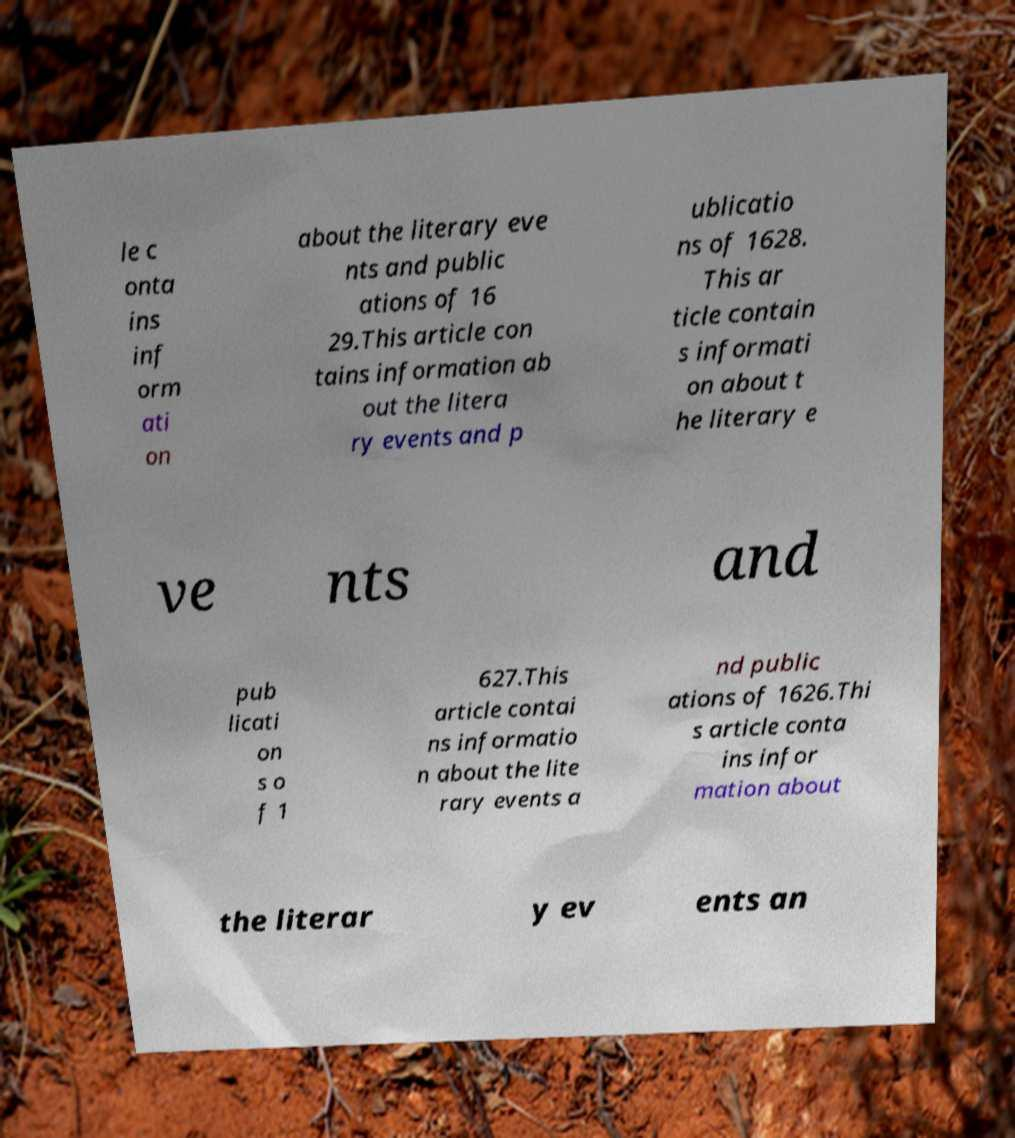Could you assist in decoding the text presented in this image and type it out clearly? le c onta ins inf orm ati on about the literary eve nts and public ations of 16 29.This article con tains information ab out the litera ry events and p ublicatio ns of 1628. This ar ticle contain s informati on about t he literary e ve nts and pub licati on s o f 1 627.This article contai ns informatio n about the lite rary events a nd public ations of 1626.Thi s article conta ins infor mation about the literar y ev ents an 